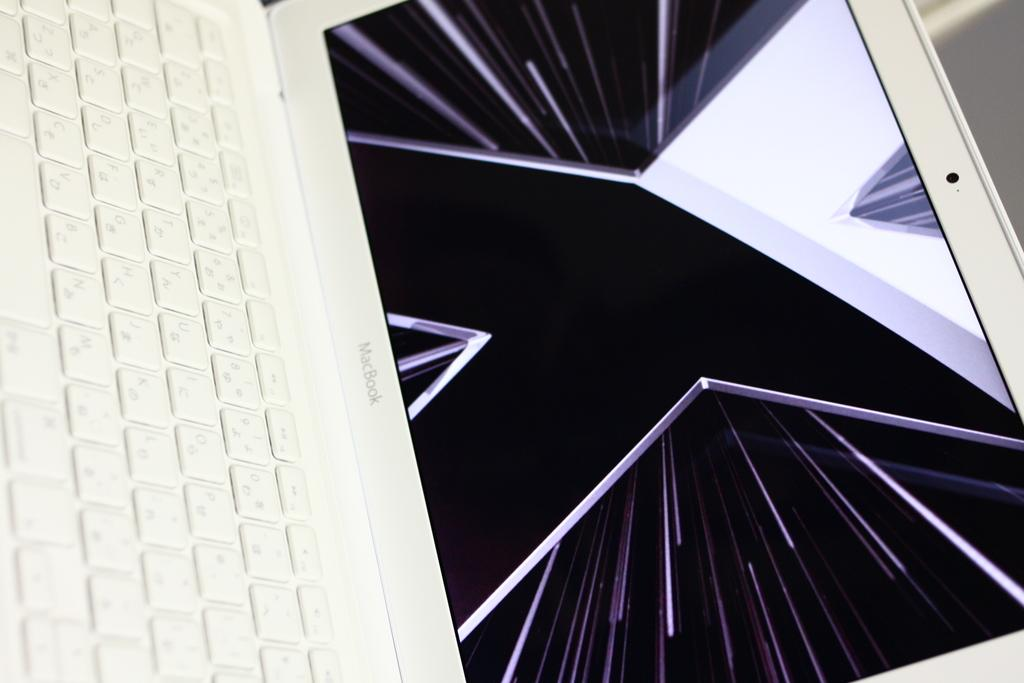What electronic device is visible in the image? There is a laptop in the image. Can you describe the background of the image? The background of the image is blurred. What type of feast is being prepared on the laptop in the image? There is no feast being prepared on the laptop in the image; it is an electronic device used for various purposes. What watch is visible on the wrist of the person using the laptop in the image? There is no watch visible on any wrist in the image. 